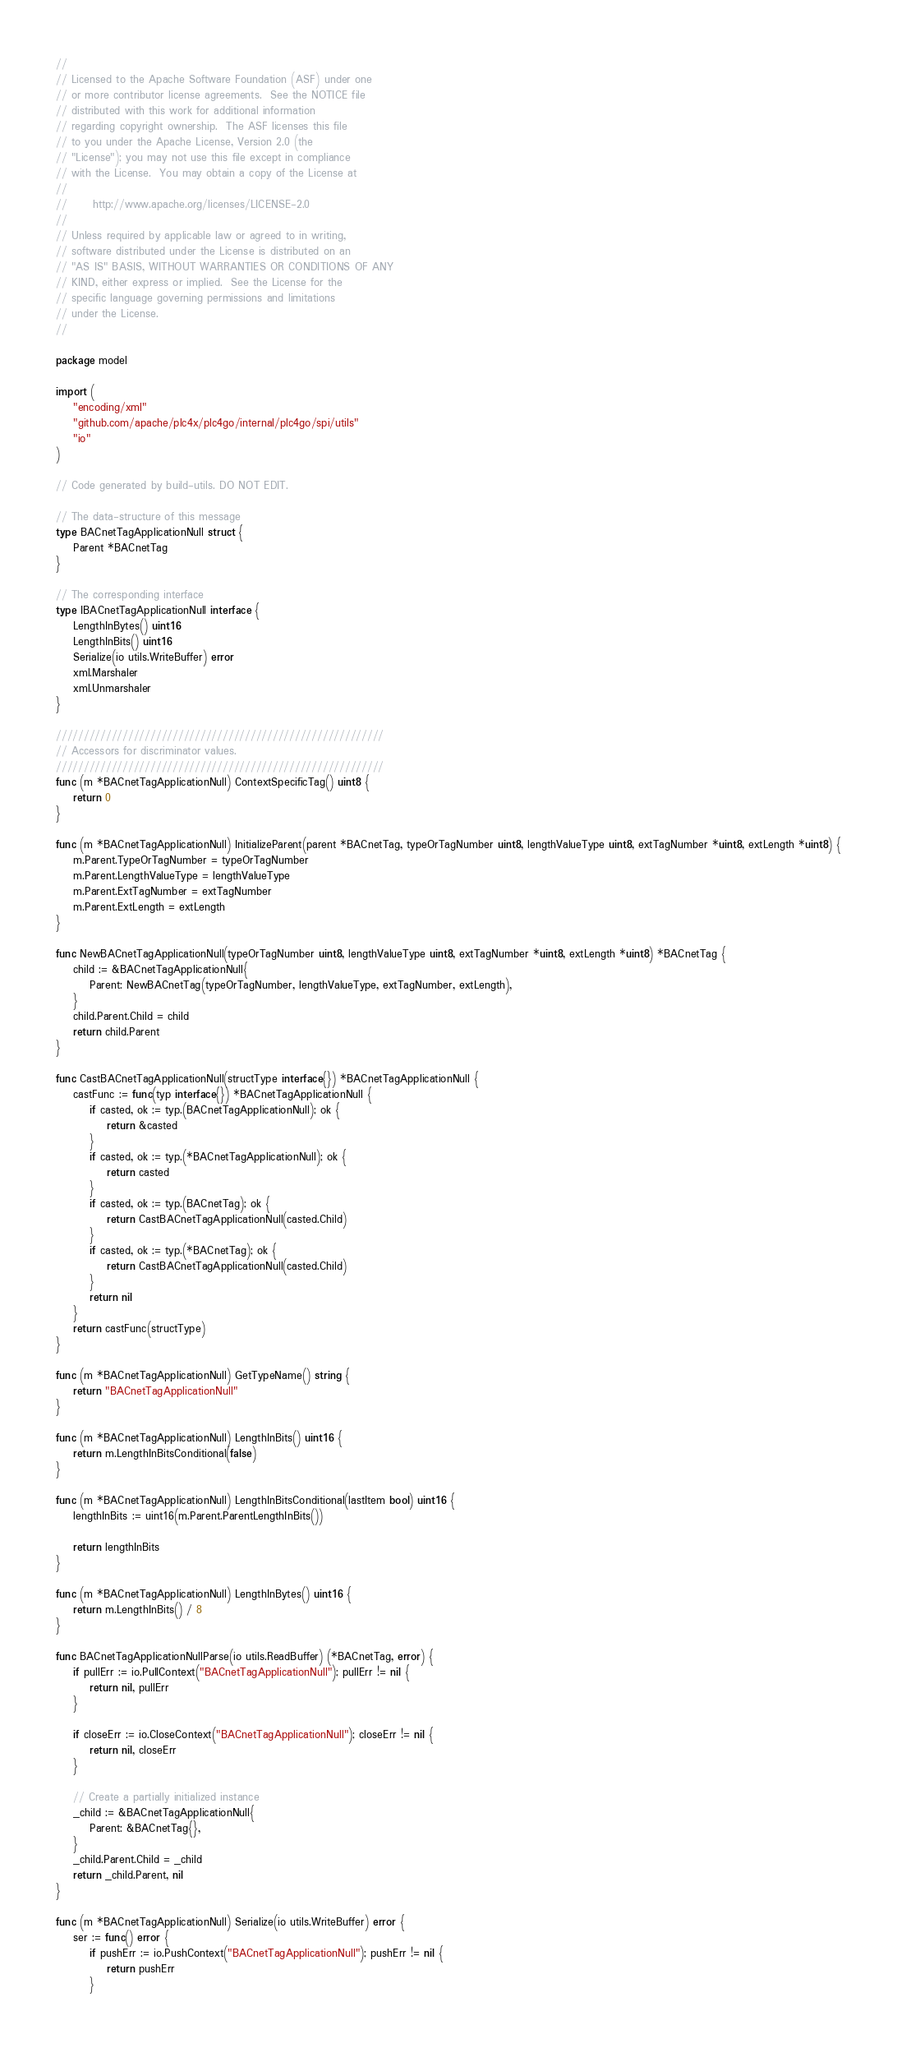<code> <loc_0><loc_0><loc_500><loc_500><_Go_>//
// Licensed to the Apache Software Foundation (ASF) under one
// or more contributor license agreements.  See the NOTICE file
// distributed with this work for additional information
// regarding copyright ownership.  The ASF licenses this file
// to you under the Apache License, Version 2.0 (the
// "License"); you may not use this file except in compliance
// with the License.  You may obtain a copy of the License at
//
//      http://www.apache.org/licenses/LICENSE-2.0
//
// Unless required by applicable law or agreed to in writing,
// software distributed under the License is distributed on an
// "AS IS" BASIS, WITHOUT WARRANTIES OR CONDITIONS OF ANY
// KIND, either express or implied.  See the License for the
// specific language governing permissions and limitations
// under the License.
//

package model

import (
	"encoding/xml"
	"github.com/apache/plc4x/plc4go/internal/plc4go/spi/utils"
	"io"
)

// Code generated by build-utils. DO NOT EDIT.

// The data-structure of this message
type BACnetTagApplicationNull struct {
	Parent *BACnetTag
}

// The corresponding interface
type IBACnetTagApplicationNull interface {
	LengthInBytes() uint16
	LengthInBits() uint16
	Serialize(io utils.WriteBuffer) error
	xml.Marshaler
	xml.Unmarshaler
}

///////////////////////////////////////////////////////////
// Accessors for discriminator values.
///////////////////////////////////////////////////////////
func (m *BACnetTagApplicationNull) ContextSpecificTag() uint8 {
	return 0
}

func (m *BACnetTagApplicationNull) InitializeParent(parent *BACnetTag, typeOrTagNumber uint8, lengthValueType uint8, extTagNumber *uint8, extLength *uint8) {
	m.Parent.TypeOrTagNumber = typeOrTagNumber
	m.Parent.LengthValueType = lengthValueType
	m.Parent.ExtTagNumber = extTagNumber
	m.Parent.ExtLength = extLength
}

func NewBACnetTagApplicationNull(typeOrTagNumber uint8, lengthValueType uint8, extTagNumber *uint8, extLength *uint8) *BACnetTag {
	child := &BACnetTagApplicationNull{
		Parent: NewBACnetTag(typeOrTagNumber, lengthValueType, extTagNumber, extLength),
	}
	child.Parent.Child = child
	return child.Parent
}

func CastBACnetTagApplicationNull(structType interface{}) *BACnetTagApplicationNull {
	castFunc := func(typ interface{}) *BACnetTagApplicationNull {
		if casted, ok := typ.(BACnetTagApplicationNull); ok {
			return &casted
		}
		if casted, ok := typ.(*BACnetTagApplicationNull); ok {
			return casted
		}
		if casted, ok := typ.(BACnetTag); ok {
			return CastBACnetTagApplicationNull(casted.Child)
		}
		if casted, ok := typ.(*BACnetTag); ok {
			return CastBACnetTagApplicationNull(casted.Child)
		}
		return nil
	}
	return castFunc(structType)
}

func (m *BACnetTagApplicationNull) GetTypeName() string {
	return "BACnetTagApplicationNull"
}

func (m *BACnetTagApplicationNull) LengthInBits() uint16 {
	return m.LengthInBitsConditional(false)
}

func (m *BACnetTagApplicationNull) LengthInBitsConditional(lastItem bool) uint16 {
	lengthInBits := uint16(m.Parent.ParentLengthInBits())

	return lengthInBits
}

func (m *BACnetTagApplicationNull) LengthInBytes() uint16 {
	return m.LengthInBits() / 8
}

func BACnetTagApplicationNullParse(io utils.ReadBuffer) (*BACnetTag, error) {
	if pullErr := io.PullContext("BACnetTagApplicationNull"); pullErr != nil {
		return nil, pullErr
	}

	if closeErr := io.CloseContext("BACnetTagApplicationNull"); closeErr != nil {
		return nil, closeErr
	}

	// Create a partially initialized instance
	_child := &BACnetTagApplicationNull{
		Parent: &BACnetTag{},
	}
	_child.Parent.Child = _child
	return _child.Parent, nil
}

func (m *BACnetTagApplicationNull) Serialize(io utils.WriteBuffer) error {
	ser := func() error {
		if pushErr := io.PushContext("BACnetTagApplicationNull"); pushErr != nil {
			return pushErr
		}
</code> 